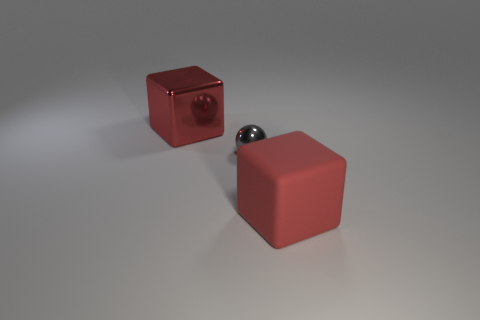Is there anything else that has the same size as the gray metal sphere?
Offer a terse response. No. What size is the shiny thing in front of the large red metal thing?
Provide a succinct answer. Small. There is a large rubber cube that is in front of the gray thing; is it the same color as the sphere?
Make the answer very short. No. There is another large red thing that is the same shape as the large red metal thing; what is its material?
Make the answer very short. Rubber. How many red rubber blocks have the same size as the gray sphere?
Your response must be concise. 0. What is the shape of the small metal thing?
Your answer should be compact. Sphere. There is a tiny sphere that is on the right side of the large red metallic object; what is its material?
Give a very brief answer. Metal. Does the big metallic object have the same color as the large cube in front of the big red metallic thing?
Make the answer very short. Yes. What number of objects are either big red things on the left side of the gray thing or large things that are left of the red rubber block?
Give a very brief answer. 1. There is a object that is both right of the large metal thing and behind the matte object; what is its color?
Provide a succinct answer. Gray. 